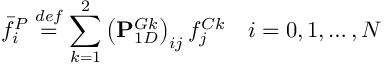Convert formula to latex. <formula><loc_0><loc_0><loc_500><loc_500>\bar { f } _ { i } ^ { P } \overset { d e f } { = } \sum _ { k = 1 } ^ { 2 } \left ( P _ { 1 D } ^ { G k } \right ) _ { i j } f _ { j } ^ { C k } \quad i = 0 , 1 , \dots , N</formula> 